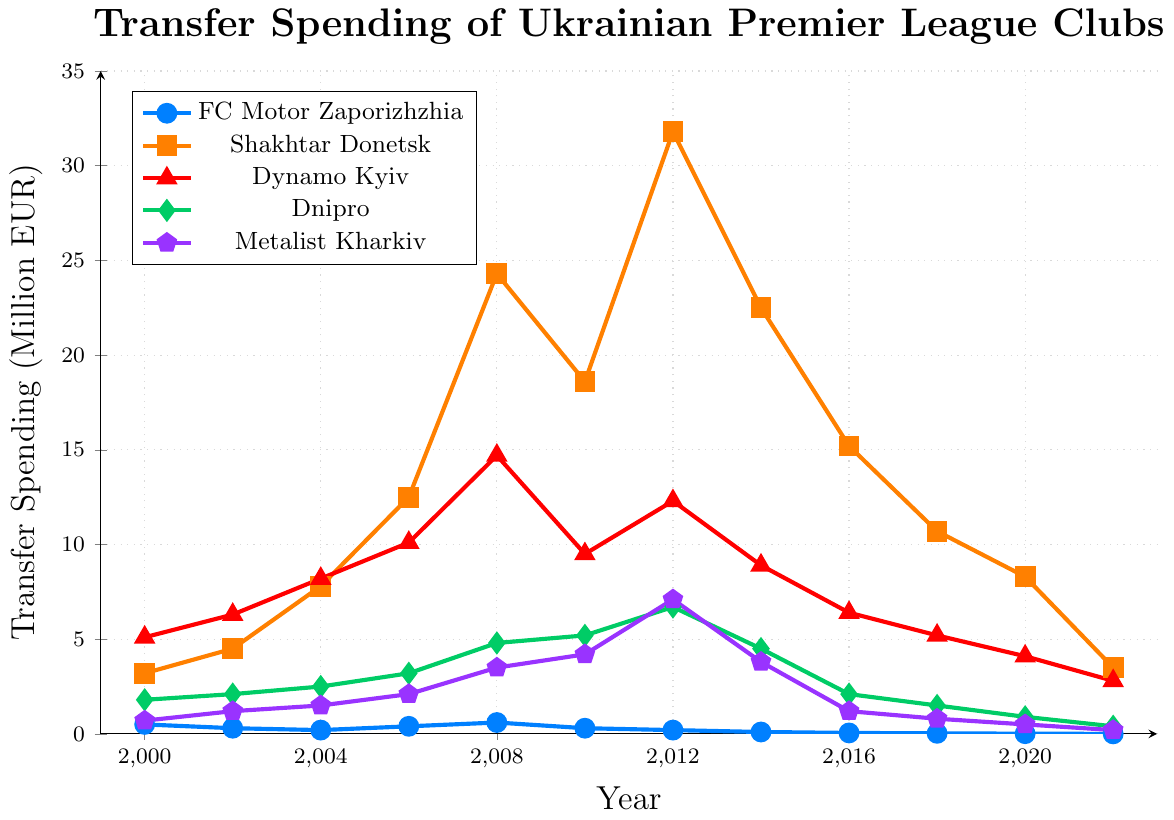Which club had the highest transfer spending in 2008? Look at the 2008 data points and observe the transfer spending values for all clubs. Shakhtar Donetsk had the highest spending of 24.3 million EUR.
Answer: Shakhtar Donetsk How does FC Motor Zaporizhzhia’s spending in 2014 compare with its spending in 2016? Check the values of FC Motor Zaporizhzhia in 2014 (0.1 million EUR) and 2016 (0.05 million EUR). Subtract 2016's value from 2014's value, which is 0.1 - 0.05 = 0.05 million EUR.
Answer: 0.05 million EUR higher in 2014 Between which years did Dynamo Kyiv’s transfer spending peak? Look at the trend for Dynamo Kyiv’s transfer spending. The highest value is 14.7 million EUR in 2008. Identify the years before and after this peak point.
Answer: 2006 and 2008 Which club had a consistently increasing transfer spending from 2000 to 2012? Analyze the transfer spending trends for each club from 2000 to 2012. Only Shakhtar Donetsk shows a consistent increase from 3.2 million EUR in 2000 to 31.8 million EUR in 2012.
Answer: Shakhtar Donetsk What is the average transfer spending of Dnipro between 2006 and 2012? Calculate the average by summing Dnipro’s spending for the years (3.2, 4.8, 5.2, 6.7) and dividing by the number of years, which is (3.2 + 4.8 + 5.2 + 6.7) / 4 = 19.9 / 4 = 4.975 million EUR.
Answer: 4.975 million EUR How did Metalist Kharkiv's spending in 2012 compare to its spending in 2022? Compare the values of Metalist Kharkiv in 2012 (7.1 million EUR) and 2022 (0.2 million EUR). Subtract 2022's value from 2012's value, which is 7.1 - 0.2 = 6.9 million EUR.
Answer: 6.9 million EUR higher in 2012 What is the trend of FC Motor Zaporizhzhia’s transfer spending from 2000 to 2022? Observe FC Motor Zaporizhzhia’s spending values starting from 0.5 million EUR in 2000 to 0 million EUR in 2022, noticing that it steadily decreases over the period.
Answer: Downward trend Between 2006 to 2008, which club had the highest increase in transfer spending? Compare the increase in spending for each club between 2006 to 2008. Shakhtar Donetsk's increase is from 12.5 to 24.3 million EUR, which is an increase of 11.8 million EUR, the highest among the clubs.
Answer: Shakhtar Donetsk How does FC Motor Zaporizhzhia’s peak spending compare to Shakhtar Donetsk's peak spending? Identify FC Motor Zaporizhzhia’s peak spending (0.6 million EUR in 2008) and Shakhtar Donetsk's peak spending (31.8 million EUR in 2012). Compare these two values.
Answer: Shakhtar Donetsk's peak is significantly higher 